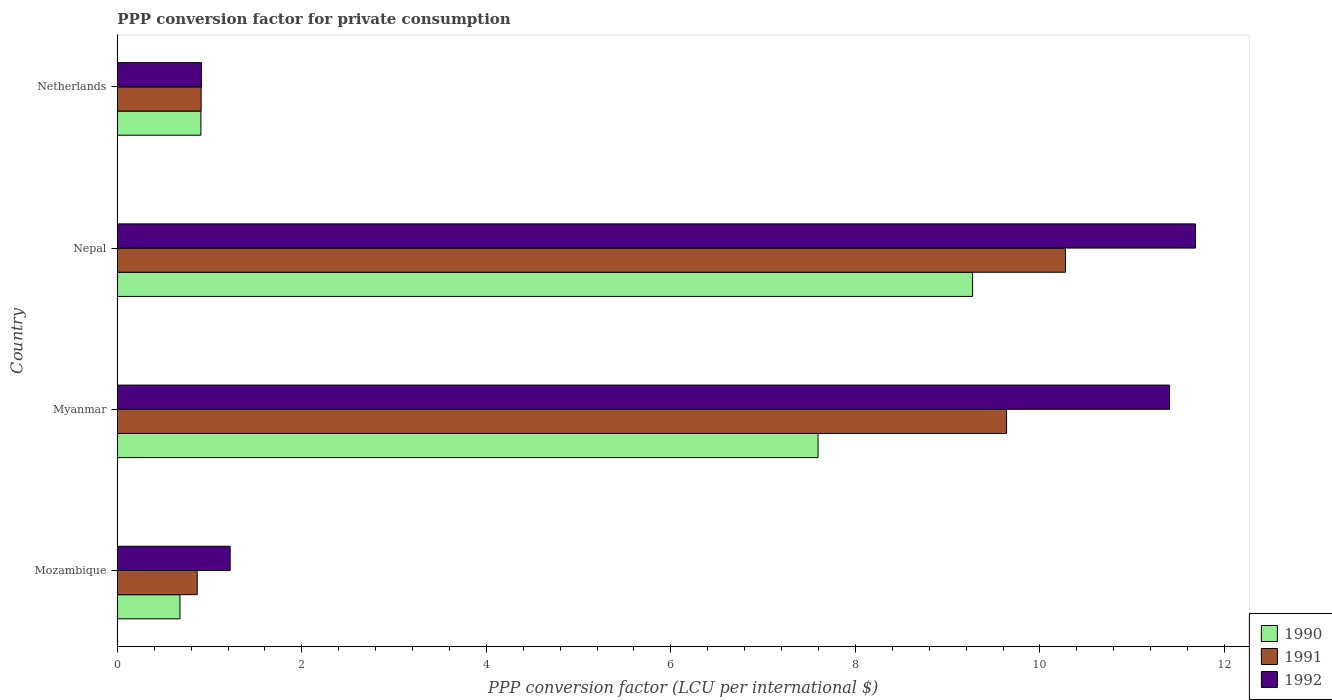How many different coloured bars are there?
Your answer should be compact. 3. Are the number of bars on each tick of the Y-axis equal?
Keep it short and to the point. Yes. How many bars are there on the 2nd tick from the top?
Make the answer very short. 3. How many bars are there on the 2nd tick from the bottom?
Give a very brief answer. 3. What is the label of the 4th group of bars from the top?
Ensure brevity in your answer.  Mozambique. In how many cases, is the number of bars for a given country not equal to the number of legend labels?
Your response must be concise. 0. What is the PPP conversion factor for private consumption in 1991 in Netherlands?
Offer a terse response. 0.91. Across all countries, what is the maximum PPP conversion factor for private consumption in 1991?
Provide a succinct answer. 10.28. Across all countries, what is the minimum PPP conversion factor for private consumption in 1991?
Keep it short and to the point. 0.87. In which country was the PPP conversion factor for private consumption in 1992 maximum?
Your answer should be very brief. Nepal. In which country was the PPP conversion factor for private consumption in 1991 minimum?
Provide a succinct answer. Mozambique. What is the total PPP conversion factor for private consumption in 1990 in the graph?
Ensure brevity in your answer.  18.45. What is the difference between the PPP conversion factor for private consumption in 1991 in Mozambique and that in Nepal?
Your answer should be compact. -9.41. What is the difference between the PPP conversion factor for private consumption in 1992 in Nepal and the PPP conversion factor for private consumption in 1991 in Mozambique?
Give a very brief answer. 10.82. What is the average PPP conversion factor for private consumption in 1991 per country?
Keep it short and to the point. 5.42. What is the difference between the PPP conversion factor for private consumption in 1990 and PPP conversion factor for private consumption in 1991 in Mozambique?
Offer a very short reply. -0.19. In how many countries, is the PPP conversion factor for private consumption in 1992 greater than 3.6 LCU?
Offer a terse response. 2. What is the ratio of the PPP conversion factor for private consumption in 1992 in Nepal to that in Netherlands?
Your response must be concise. 12.8. Is the PPP conversion factor for private consumption in 1991 in Nepal less than that in Netherlands?
Give a very brief answer. No. What is the difference between the highest and the second highest PPP conversion factor for private consumption in 1992?
Provide a succinct answer. 0.28. What is the difference between the highest and the lowest PPP conversion factor for private consumption in 1990?
Your answer should be very brief. 8.59. What does the 1st bar from the bottom in Mozambique represents?
Your response must be concise. 1990. How many bars are there?
Give a very brief answer. 12. How many countries are there in the graph?
Make the answer very short. 4. What is the difference between two consecutive major ticks on the X-axis?
Your answer should be very brief. 2. Where does the legend appear in the graph?
Your answer should be very brief. Bottom right. What is the title of the graph?
Your response must be concise. PPP conversion factor for private consumption. Does "1973" appear as one of the legend labels in the graph?
Provide a short and direct response. No. What is the label or title of the X-axis?
Your answer should be compact. PPP conversion factor (LCU per international $). What is the PPP conversion factor (LCU per international $) in 1990 in Mozambique?
Provide a succinct answer. 0.68. What is the PPP conversion factor (LCU per international $) in 1991 in Mozambique?
Offer a very short reply. 0.87. What is the PPP conversion factor (LCU per international $) of 1992 in Mozambique?
Your answer should be compact. 1.22. What is the PPP conversion factor (LCU per international $) in 1990 in Myanmar?
Offer a very short reply. 7.6. What is the PPP conversion factor (LCU per international $) in 1991 in Myanmar?
Your response must be concise. 9.64. What is the PPP conversion factor (LCU per international $) in 1992 in Myanmar?
Keep it short and to the point. 11.41. What is the PPP conversion factor (LCU per international $) in 1990 in Nepal?
Your answer should be very brief. 9.27. What is the PPP conversion factor (LCU per international $) of 1991 in Nepal?
Make the answer very short. 10.28. What is the PPP conversion factor (LCU per international $) in 1992 in Nepal?
Offer a very short reply. 11.69. What is the PPP conversion factor (LCU per international $) in 1990 in Netherlands?
Keep it short and to the point. 0.91. What is the PPP conversion factor (LCU per international $) in 1991 in Netherlands?
Your answer should be compact. 0.91. What is the PPP conversion factor (LCU per international $) in 1992 in Netherlands?
Your answer should be compact. 0.91. Across all countries, what is the maximum PPP conversion factor (LCU per international $) in 1990?
Offer a terse response. 9.27. Across all countries, what is the maximum PPP conversion factor (LCU per international $) of 1991?
Your answer should be compact. 10.28. Across all countries, what is the maximum PPP conversion factor (LCU per international $) in 1992?
Make the answer very short. 11.69. Across all countries, what is the minimum PPP conversion factor (LCU per international $) in 1990?
Provide a short and direct response. 0.68. Across all countries, what is the minimum PPP conversion factor (LCU per international $) of 1991?
Give a very brief answer. 0.87. Across all countries, what is the minimum PPP conversion factor (LCU per international $) of 1992?
Ensure brevity in your answer.  0.91. What is the total PPP conversion factor (LCU per international $) in 1990 in the graph?
Provide a succinct answer. 18.45. What is the total PPP conversion factor (LCU per international $) of 1991 in the graph?
Ensure brevity in your answer.  21.69. What is the total PPP conversion factor (LCU per international $) in 1992 in the graph?
Make the answer very short. 25.23. What is the difference between the PPP conversion factor (LCU per international $) in 1990 in Mozambique and that in Myanmar?
Ensure brevity in your answer.  -6.92. What is the difference between the PPP conversion factor (LCU per international $) in 1991 in Mozambique and that in Myanmar?
Offer a very short reply. -8.77. What is the difference between the PPP conversion factor (LCU per international $) in 1992 in Mozambique and that in Myanmar?
Provide a succinct answer. -10.18. What is the difference between the PPP conversion factor (LCU per international $) in 1990 in Mozambique and that in Nepal?
Make the answer very short. -8.59. What is the difference between the PPP conversion factor (LCU per international $) in 1991 in Mozambique and that in Nepal?
Give a very brief answer. -9.41. What is the difference between the PPP conversion factor (LCU per international $) in 1992 in Mozambique and that in Nepal?
Offer a very short reply. -10.46. What is the difference between the PPP conversion factor (LCU per international $) in 1990 in Mozambique and that in Netherlands?
Make the answer very short. -0.23. What is the difference between the PPP conversion factor (LCU per international $) of 1991 in Mozambique and that in Netherlands?
Your answer should be very brief. -0.04. What is the difference between the PPP conversion factor (LCU per international $) of 1992 in Mozambique and that in Netherlands?
Your answer should be compact. 0.31. What is the difference between the PPP conversion factor (LCU per international $) in 1990 in Myanmar and that in Nepal?
Give a very brief answer. -1.67. What is the difference between the PPP conversion factor (LCU per international $) in 1991 in Myanmar and that in Nepal?
Make the answer very short. -0.64. What is the difference between the PPP conversion factor (LCU per international $) of 1992 in Myanmar and that in Nepal?
Keep it short and to the point. -0.28. What is the difference between the PPP conversion factor (LCU per international $) of 1990 in Myanmar and that in Netherlands?
Your answer should be very brief. 6.69. What is the difference between the PPP conversion factor (LCU per international $) of 1991 in Myanmar and that in Netherlands?
Provide a succinct answer. 8.73. What is the difference between the PPP conversion factor (LCU per international $) of 1992 in Myanmar and that in Netherlands?
Offer a terse response. 10.49. What is the difference between the PPP conversion factor (LCU per international $) in 1990 in Nepal and that in Netherlands?
Your answer should be compact. 8.36. What is the difference between the PPP conversion factor (LCU per international $) of 1991 in Nepal and that in Netherlands?
Give a very brief answer. 9.37. What is the difference between the PPP conversion factor (LCU per international $) of 1992 in Nepal and that in Netherlands?
Make the answer very short. 10.77. What is the difference between the PPP conversion factor (LCU per international $) in 1990 in Mozambique and the PPP conversion factor (LCU per international $) in 1991 in Myanmar?
Your response must be concise. -8.96. What is the difference between the PPP conversion factor (LCU per international $) of 1990 in Mozambique and the PPP conversion factor (LCU per international $) of 1992 in Myanmar?
Ensure brevity in your answer.  -10.73. What is the difference between the PPP conversion factor (LCU per international $) of 1991 in Mozambique and the PPP conversion factor (LCU per international $) of 1992 in Myanmar?
Your response must be concise. -10.54. What is the difference between the PPP conversion factor (LCU per international $) of 1990 in Mozambique and the PPP conversion factor (LCU per international $) of 1991 in Nepal?
Your answer should be very brief. -9.6. What is the difference between the PPP conversion factor (LCU per international $) of 1990 in Mozambique and the PPP conversion factor (LCU per international $) of 1992 in Nepal?
Give a very brief answer. -11.01. What is the difference between the PPP conversion factor (LCU per international $) of 1991 in Mozambique and the PPP conversion factor (LCU per international $) of 1992 in Nepal?
Your response must be concise. -10.82. What is the difference between the PPP conversion factor (LCU per international $) in 1990 in Mozambique and the PPP conversion factor (LCU per international $) in 1991 in Netherlands?
Offer a very short reply. -0.23. What is the difference between the PPP conversion factor (LCU per international $) in 1990 in Mozambique and the PPP conversion factor (LCU per international $) in 1992 in Netherlands?
Your response must be concise. -0.23. What is the difference between the PPP conversion factor (LCU per international $) in 1991 in Mozambique and the PPP conversion factor (LCU per international $) in 1992 in Netherlands?
Offer a very short reply. -0.05. What is the difference between the PPP conversion factor (LCU per international $) in 1990 in Myanmar and the PPP conversion factor (LCU per international $) in 1991 in Nepal?
Your response must be concise. -2.68. What is the difference between the PPP conversion factor (LCU per international $) in 1990 in Myanmar and the PPP conversion factor (LCU per international $) in 1992 in Nepal?
Provide a succinct answer. -4.09. What is the difference between the PPP conversion factor (LCU per international $) in 1991 in Myanmar and the PPP conversion factor (LCU per international $) in 1992 in Nepal?
Your response must be concise. -2.05. What is the difference between the PPP conversion factor (LCU per international $) in 1990 in Myanmar and the PPP conversion factor (LCU per international $) in 1991 in Netherlands?
Give a very brief answer. 6.69. What is the difference between the PPP conversion factor (LCU per international $) of 1990 in Myanmar and the PPP conversion factor (LCU per international $) of 1992 in Netherlands?
Offer a very short reply. 6.68. What is the difference between the PPP conversion factor (LCU per international $) of 1991 in Myanmar and the PPP conversion factor (LCU per international $) of 1992 in Netherlands?
Your response must be concise. 8.73. What is the difference between the PPP conversion factor (LCU per international $) in 1990 in Nepal and the PPP conversion factor (LCU per international $) in 1991 in Netherlands?
Offer a terse response. 8.36. What is the difference between the PPP conversion factor (LCU per international $) of 1990 in Nepal and the PPP conversion factor (LCU per international $) of 1992 in Netherlands?
Offer a terse response. 8.36. What is the difference between the PPP conversion factor (LCU per international $) of 1991 in Nepal and the PPP conversion factor (LCU per international $) of 1992 in Netherlands?
Your answer should be very brief. 9.36. What is the average PPP conversion factor (LCU per international $) of 1990 per country?
Make the answer very short. 4.61. What is the average PPP conversion factor (LCU per international $) of 1991 per country?
Make the answer very short. 5.42. What is the average PPP conversion factor (LCU per international $) of 1992 per country?
Provide a short and direct response. 6.31. What is the difference between the PPP conversion factor (LCU per international $) in 1990 and PPP conversion factor (LCU per international $) in 1991 in Mozambique?
Provide a short and direct response. -0.19. What is the difference between the PPP conversion factor (LCU per international $) of 1990 and PPP conversion factor (LCU per international $) of 1992 in Mozambique?
Provide a short and direct response. -0.54. What is the difference between the PPP conversion factor (LCU per international $) in 1991 and PPP conversion factor (LCU per international $) in 1992 in Mozambique?
Your answer should be very brief. -0.36. What is the difference between the PPP conversion factor (LCU per international $) of 1990 and PPP conversion factor (LCU per international $) of 1991 in Myanmar?
Keep it short and to the point. -2.04. What is the difference between the PPP conversion factor (LCU per international $) of 1990 and PPP conversion factor (LCU per international $) of 1992 in Myanmar?
Provide a short and direct response. -3.81. What is the difference between the PPP conversion factor (LCU per international $) in 1991 and PPP conversion factor (LCU per international $) in 1992 in Myanmar?
Ensure brevity in your answer.  -1.77. What is the difference between the PPP conversion factor (LCU per international $) in 1990 and PPP conversion factor (LCU per international $) in 1991 in Nepal?
Keep it short and to the point. -1.01. What is the difference between the PPP conversion factor (LCU per international $) in 1990 and PPP conversion factor (LCU per international $) in 1992 in Nepal?
Provide a short and direct response. -2.42. What is the difference between the PPP conversion factor (LCU per international $) of 1991 and PPP conversion factor (LCU per international $) of 1992 in Nepal?
Make the answer very short. -1.41. What is the difference between the PPP conversion factor (LCU per international $) in 1990 and PPP conversion factor (LCU per international $) in 1991 in Netherlands?
Your response must be concise. -0. What is the difference between the PPP conversion factor (LCU per international $) in 1990 and PPP conversion factor (LCU per international $) in 1992 in Netherlands?
Ensure brevity in your answer.  -0.01. What is the difference between the PPP conversion factor (LCU per international $) of 1991 and PPP conversion factor (LCU per international $) of 1992 in Netherlands?
Keep it short and to the point. -0. What is the ratio of the PPP conversion factor (LCU per international $) of 1990 in Mozambique to that in Myanmar?
Offer a very short reply. 0.09. What is the ratio of the PPP conversion factor (LCU per international $) of 1991 in Mozambique to that in Myanmar?
Provide a succinct answer. 0.09. What is the ratio of the PPP conversion factor (LCU per international $) in 1992 in Mozambique to that in Myanmar?
Give a very brief answer. 0.11. What is the ratio of the PPP conversion factor (LCU per international $) of 1990 in Mozambique to that in Nepal?
Provide a succinct answer. 0.07. What is the ratio of the PPP conversion factor (LCU per international $) of 1991 in Mozambique to that in Nepal?
Your answer should be compact. 0.08. What is the ratio of the PPP conversion factor (LCU per international $) of 1992 in Mozambique to that in Nepal?
Offer a very short reply. 0.1. What is the ratio of the PPP conversion factor (LCU per international $) of 1990 in Mozambique to that in Netherlands?
Give a very brief answer. 0.75. What is the ratio of the PPP conversion factor (LCU per international $) in 1991 in Mozambique to that in Netherlands?
Your answer should be compact. 0.95. What is the ratio of the PPP conversion factor (LCU per international $) in 1992 in Mozambique to that in Netherlands?
Your answer should be very brief. 1.34. What is the ratio of the PPP conversion factor (LCU per international $) of 1990 in Myanmar to that in Nepal?
Give a very brief answer. 0.82. What is the ratio of the PPP conversion factor (LCU per international $) in 1991 in Myanmar to that in Nepal?
Your answer should be very brief. 0.94. What is the ratio of the PPP conversion factor (LCU per international $) of 1990 in Myanmar to that in Netherlands?
Offer a very short reply. 8.38. What is the ratio of the PPP conversion factor (LCU per international $) in 1991 in Myanmar to that in Netherlands?
Offer a very short reply. 10.6. What is the ratio of the PPP conversion factor (LCU per international $) in 1992 in Myanmar to that in Netherlands?
Keep it short and to the point. 12.49. What is the ratio of the PPP conversion factor (LCU per international $) of 1990 in Nepal to that in Netherlands?
Ensure brevity in your answer.  10.23. What is the ratio of the PPP conversion factor (LCU per international $) in 1991 in Nepal to that in Netherlands?
Keep it short and to the point. 11.31. What is the ratio of the PPP conversion factor (LCU per international $) in 1992 in Nepal to that in Netherlands?
Provide a succinct answer. 12.8. What is the difference between the highest and the second highest PPP conversion factor (LCU per international $) of 1990?
Give a very brief answer. 1.67. What is the difference between the highest and the second highest PPP conversion factor (LCU per international $) of 1991?
Your response must be concise. 0.64. What is the difference between the highest and the second highest PPP conversion factor (LCU per international $) in 1992?
Give a very brief answer. 0.28. What is the difference between the highest and the lowest PPP conversion factor (LCU per international $) in 1990?
Provide a succinct answer. 8.59. What is the difference between the highest and the lowest PPP conversion factor (LCU per international $) of 1991?
Your answer should be very brief. 9.41. What is the difference between the highest and the lowest PPP conversion factor (LCU per international $) of 1992?
Offer a terse response. 10.77. 